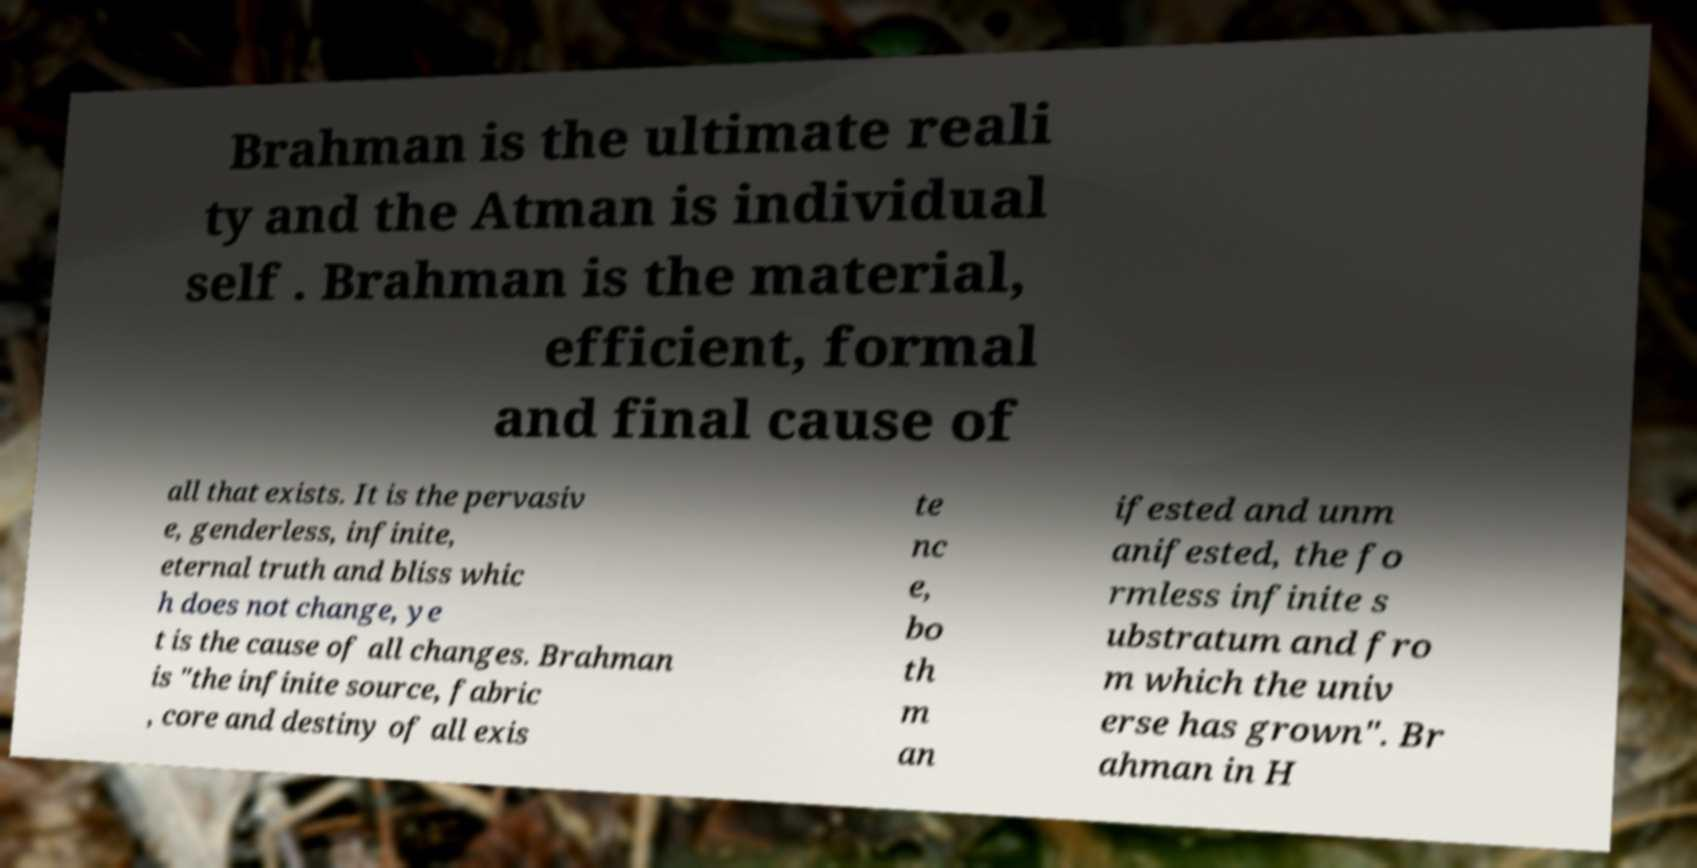Could you assist in decoding the text presented in this image and type it out clearly? Brahman is the ultimate reali ty and the Atman is individual self . Brahman is the material, efficient, formal and final cause of all that exists. It is the pervasiv e, genderless, infinite, eternal truth and bliss whic h does not change, ye t is the cause of all changes. Brahman is "the infinite source, fabric , core and destiny of all exis te nc e, bo th m an ifested and unm anifested, the fo rmless infinite s ubstratum and fro m which the univ erse has grown". Br ahman in H 